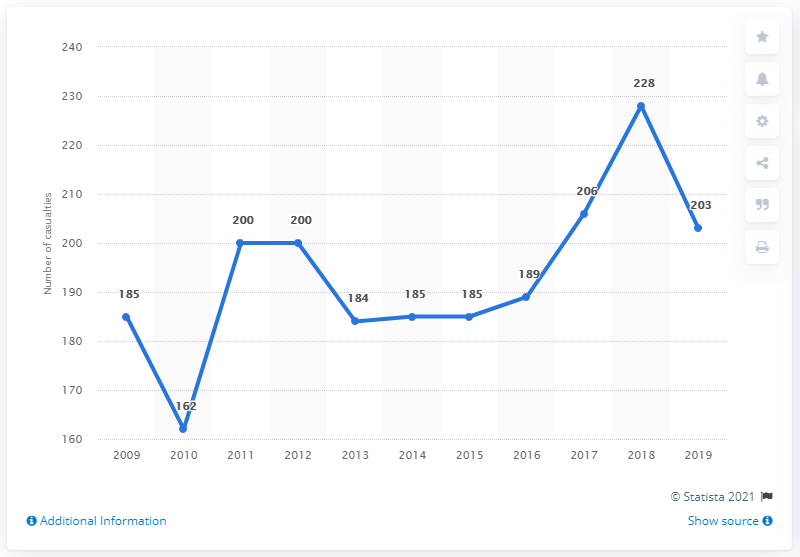Point out several critical features in this image. In 2018, the number of cyclists killed reached its maximum. The average number of deaths from 2013 to 2016 was 185.75. 